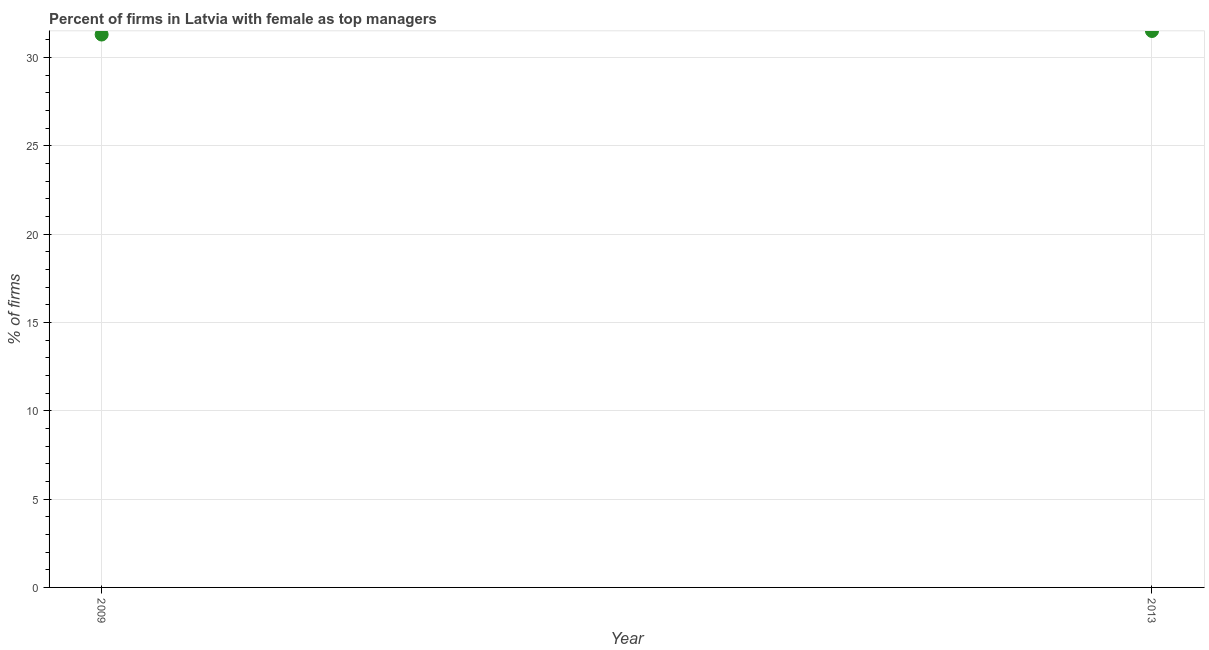What is the percentage of firms with female as top manager in 2013?
Make the answer very short. 31.5. Across all years, what is the maximum percentage of firms with female as top manager?
Your response must be concise. 31.5. Across all years, what is the minimum percentage of firms with female as top manager?
Your answer should be compact. 31.3. In which year was the percentage of firms with female as top manager maximum?
Offer a terse response. 2013. In which year was the percentage of firms with female as top manager minimum?
Your answer should be compact. 2009. What is the sum of the percentage of firms with female as top manager?
Offer a very short reply. 62.8. What is the difference between the percentage of firms with female as top manager in 2009 and 2013?
Offer a very short reply. -0.2. What is the average percentage of firms with female as top manager per year?
Your response must be concise. 31.4. What is the median percentage of firms with female as top manager?
Your answer should be compact. 31.4. What is the ratio of the percentage of firms with female as top manager in 2009 to that in 2013?
Your answer should be compact. 0.99. In how many years, is the percentage of firms with female as top manager greater than the average percentage of firms with female as top manager taken over all years?
Offer a very short reply. 1. How many years are there in the graph?
Your answer should be very brief. 2. Are the values on the major ticks of Y-axis written in scientific E-notation?
Ensure brevity in your answer.  No. Does the graph contain any zero values?
Your answer should be compact. No. Does the graph contain grids?
Keep it short and to the point. Yes. What is the title of the graph?
Offer a very short reply. Percent of firms in Latvia with female as top managers. What is the label or title of the X-axis?
Keep it short and to the point. Year. What is the label or title of the Y-axis?
Ensure brevity in your answer.  % of firms. What is the % of firms in 2009?
Your response must be concise. 31.3. What is the % of firms in 2013?
Keep it short and to the point. 31.5. 